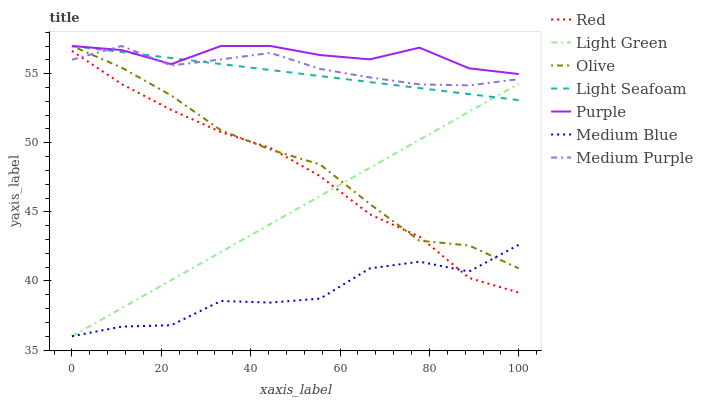Does Medium Blue have the minimum area under the curve?
Answer yes or no. Yes. Does Purple have the maximum area under the curve?
Answer yes or no. Yes. Does Medium Purple have the minimum area under the curve?
Answer yes or no. No. Does Medium Purple have the maximum area under the curve?
Answer yes or no. No. Is Light Green the smoothest?
Answer yes or no. Yes. Is Medium Blue the roughest?
Answer yes or no. Yes. Is Medium Purple the smoothest?
Answer yes or no. No. Is Medium Purple the roughest?
Answer yes or no. No. Does Medium Blue have the lowest value?
Answer yes or no. Yes. Does Medium Purple have the lowest value?
Answer yes or no. No. Does Light Seafoam have the highest value?
Answer yes or no. Yes. Does Medium Blue have the highest value?
Answer yes or no. No. Is Medium Blue less than Light Seafoam?
Answer yes or no. Yes. Is Light Seafoam greater than Red?
Answer yes or no. Yes. Does Medium Purple intersect Purple?
Answer yes or no. Yes. Is Medium Purple less than Purple?
Answer yes or no. No. Is Medium Purple greater than Purple?
Answer yes or no. No. Does Medium Blue intersect Light Seafoam?
Answer yes or no. No. 